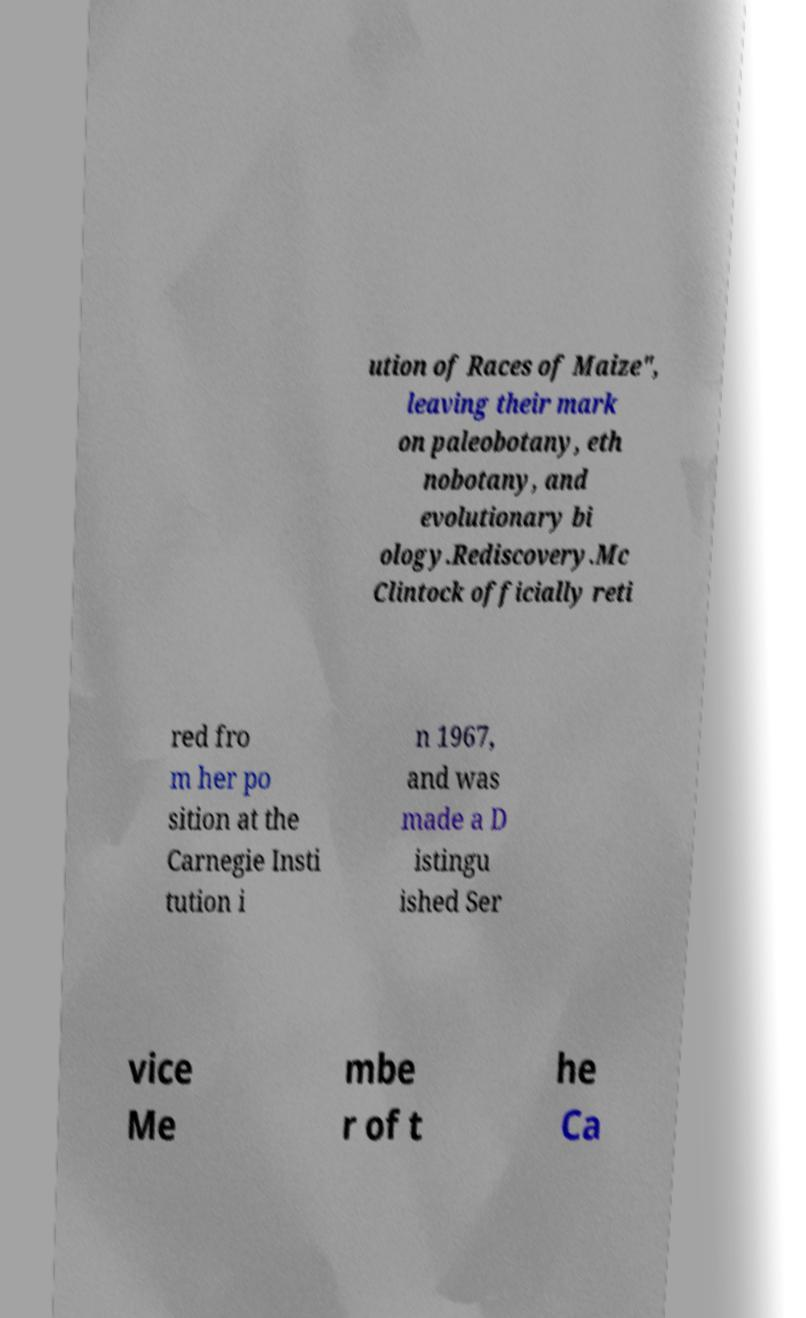Please identify and transcribe the text found in this image. ution of Races of Maize", leaving their mark on paleobotany, eth nobotany, and evolutionary bi ology.Rediscovery.Mc Clintock officially reti red fro m her po sition at the Carnegie Insti tution i n 1967, and was made a D istingu ished Ser vice Me mbe r of t he Ca 